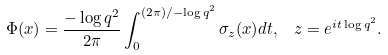Convert formula to latex. <formula><loc_0><loc_0><loc_500><loc_500>\Phi ( x ) = \frac { - \log q ^ { 2 } } { 2 \pi } \int _ { 0 } ^ { ( 2 \pi ) / - \log q ^ { 2 } } \sigma _ { z } ( x ) d t , \ \ z = e ^ { i t \log q ^ { 2 } } .</formula> 